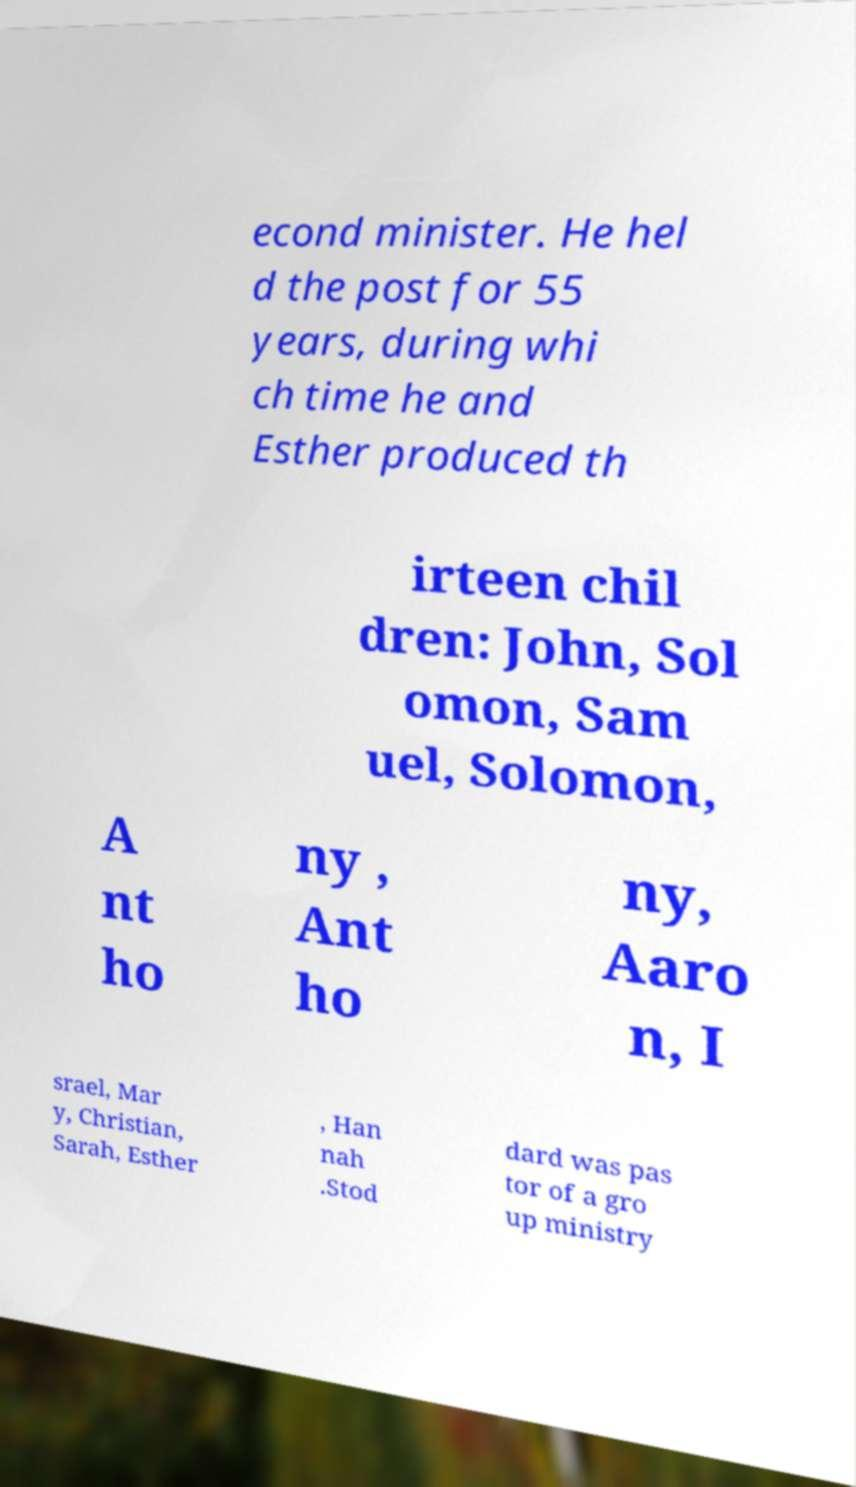There's text embedded in this image that I need extracted. Can you transcribe it verbatim? econd minister. He hel d the post for 55 years, during whi ch time he and Esther produced th irteen chil dren: John, Sol omon, Sam uel, Solomon, A nt ho ny , Ant ho ny, Aaro n, I srael, Mar y, Christian, Sarah, Esther , Han nah .Stod dard was pas tor of a gro up ministry 